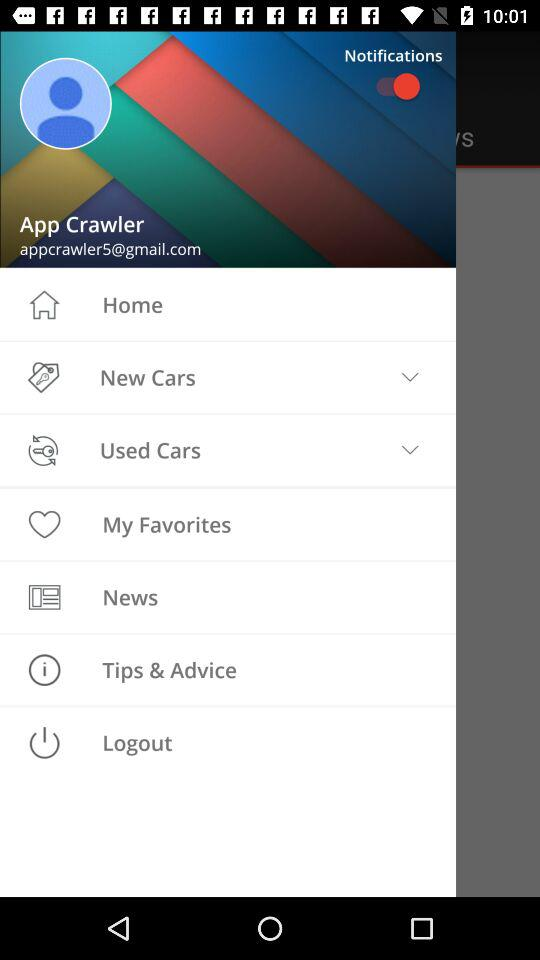What is the status of notifications? The status is on. 